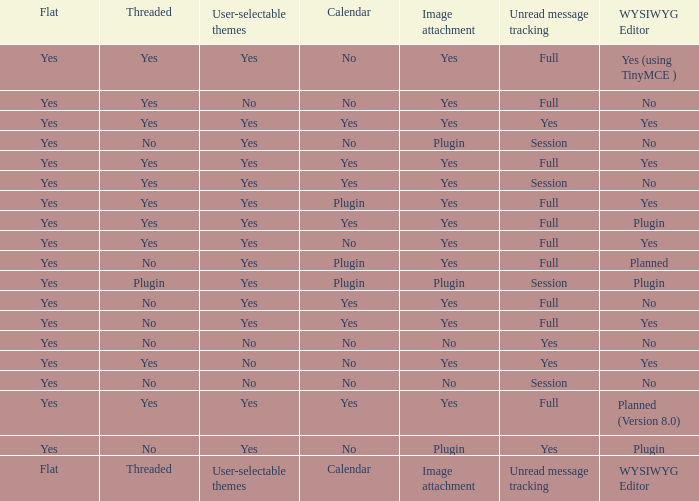Which Calendar has a User-selectable themes of user-selectable themes? Calendar. Parse the full table. {'header': ['Flat', 'Threaded', 'User-selectable themes', 'Calendar', 'Image attachment', 'Unread message tracking', 'WYSIWYG Editor'], 'rows': [['Yes', 'Yes', 'Yes', 'No', 'Yes', 'Full', 'Yes (using TinyMCE )'], ['Yes', 'Yes', 'No', 'No', 'Yes', 'Full', 'No'], ['Yes', 'Yes', 'Yes', 'Yes', 'Yes', 'Yes', 'Yes'], ['Yes', 'No', 'Yes', 'No', 'Plugin', 'Session', 'No'], ['Yes', 'Yes', 'Yes', 'Yes', 'Yes', 'Full', 'Yes'], ['Yes', 'Yes', 'Yes', 'Yes', 'Yes', 'Session', 'No'], ['Yes', 'Yes', 'Yes', 'Plugin', 'Yes', 'Full', 'Yes'], ['Yes', 'Yes', 'Yes', 'Yes', 'Yes', 'Full', 'Plugin'], ['Yes', 'Yes', 'Yes', 'No', 'Yes', 'Full', 'Yes'], ['Yes', 'No', 'Yes', 'Plugin', 'Yes', 'Full', 'Planned'], ['Yes', 'Plugin', 'Yes', 'Plugin', 'Plugin', 'Session', 'Plugin'], ['Yes', 'No', 'Yes', 'Yes', 'Yes', 'Full', 'No'], ['Yes', 'No', 'Yes', 'Yes', 'Yes', 'Full', 'Yes'], ['Yes', 'No', 'No', 'No', 'No', 'Yes', 'No'], ['Yes', 'Yes', 'No', 'No', 'Yes', 'Yes', 'Yes'], ['Yes', 'No', 'No', 'No', 'No', 'Session', 'No'], ['Yes', 'Yes', 'Yes', 'Yes', 'Yes', 'Full', 'Planned (Version 8.0)'], ['Yes', 'No', 'Yes', 'No', 'Plugin', 'Yes', 'Plugin'], ['Flat', 'Threaded', 'User-selectable themes', 'Calendar', 'Image attachment', 'Unread message tracking', 'WYSIWYG Editor']]} 